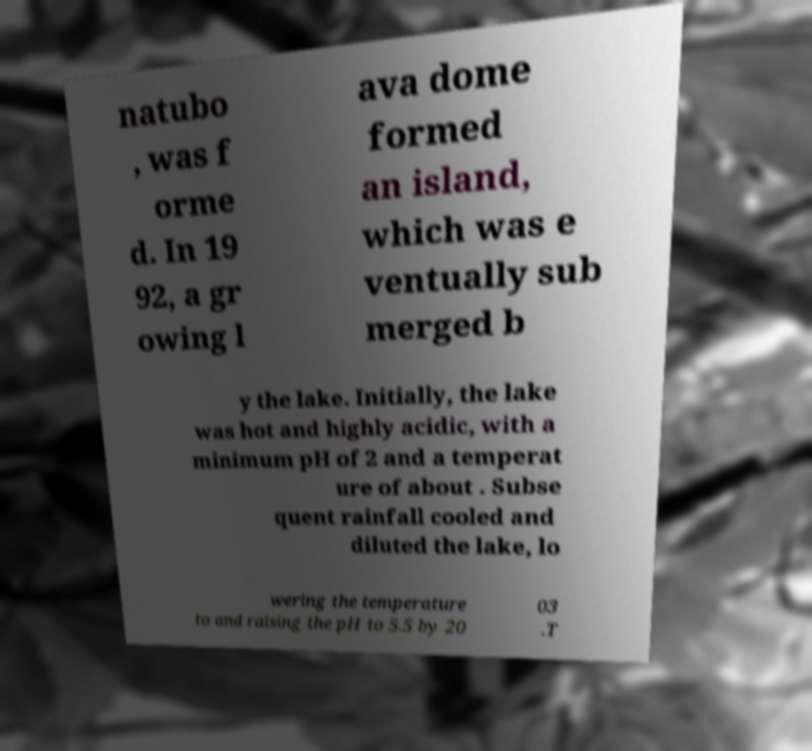Could you extract and type out the text from this image? natubo , was f orme d. In 19 92, a gr owing l ava dome formed an island, which was e ventually sub merged b y the lake. Initially, the lake was hot and highly acidic, with a minimum pH of 2 and a temperat ure of about . Subse quent rainfall cooled and diluted the lake, lo wering the temperature to and raising the pH to 5.5 by 20 03 .T 